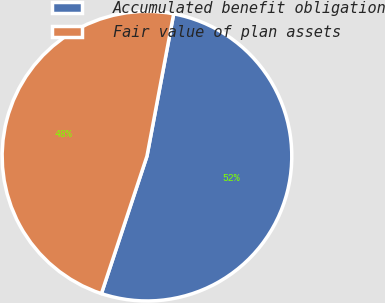<chart> <loc_0><loc_0><loc_500><loc_500><pie_chart><fcel>Accumulated benefit obligation<fcel>Fair value of plan assets<nl><fcel>52.14%<fcel>47.86%<nl></chart> 